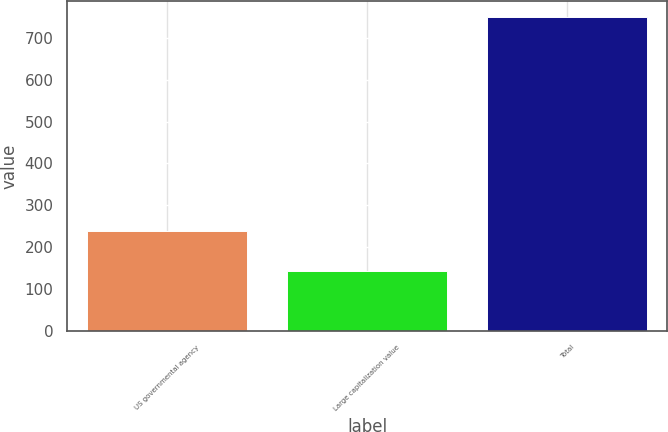Convert chart. <chart><loc_0><loc_0><loc_500><loc_500><bar_chart><fcel>US governmental agency<fcel>Large capitalization value<fcel>Total<nl><fcel>239<fcel>143<fcel>750<nl></chart> 